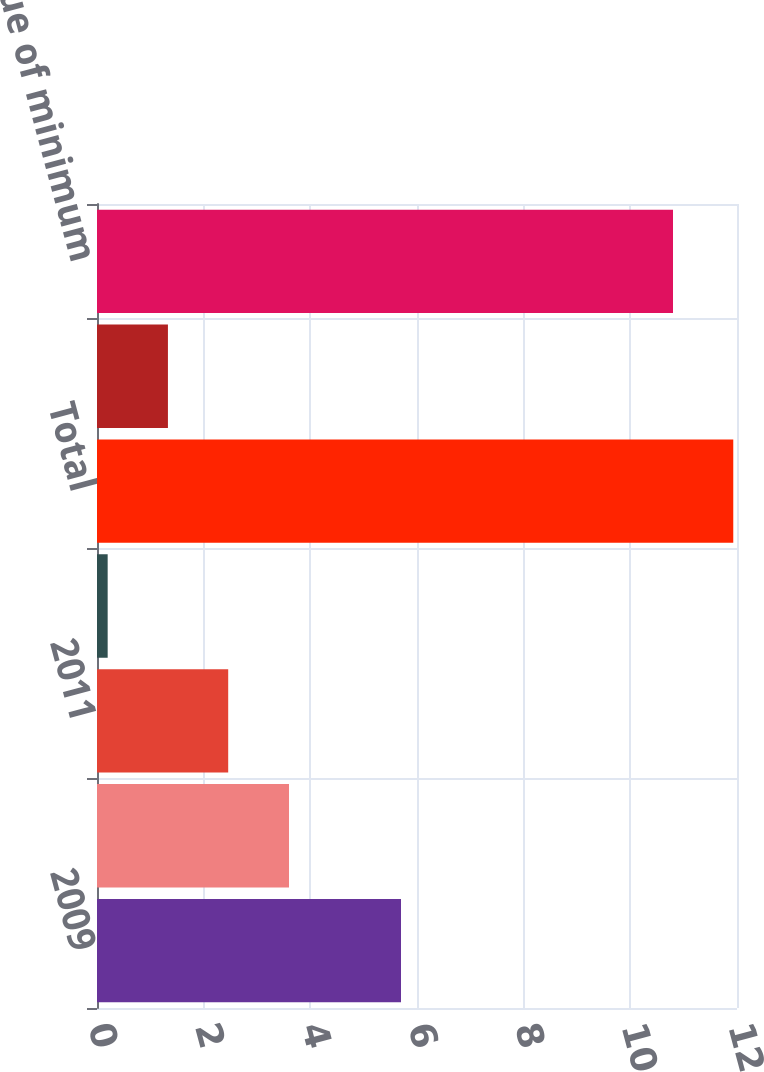Convert chart to OTSL. <chart><loc_0><loc_0><loc_500><loc_500><bar_chart><fcel>2009<fcel>2010<fcel>2011<fcel>2012<fcel>Total<fcel>Less Amounts representing<fcel>Net present value of minimum<nl><fcel>5.7<fcel>3.6<fcel>2.46<fcel>0.2<fcel>11.93<fcel>1.33<fcel>10.8<nl></chart> 